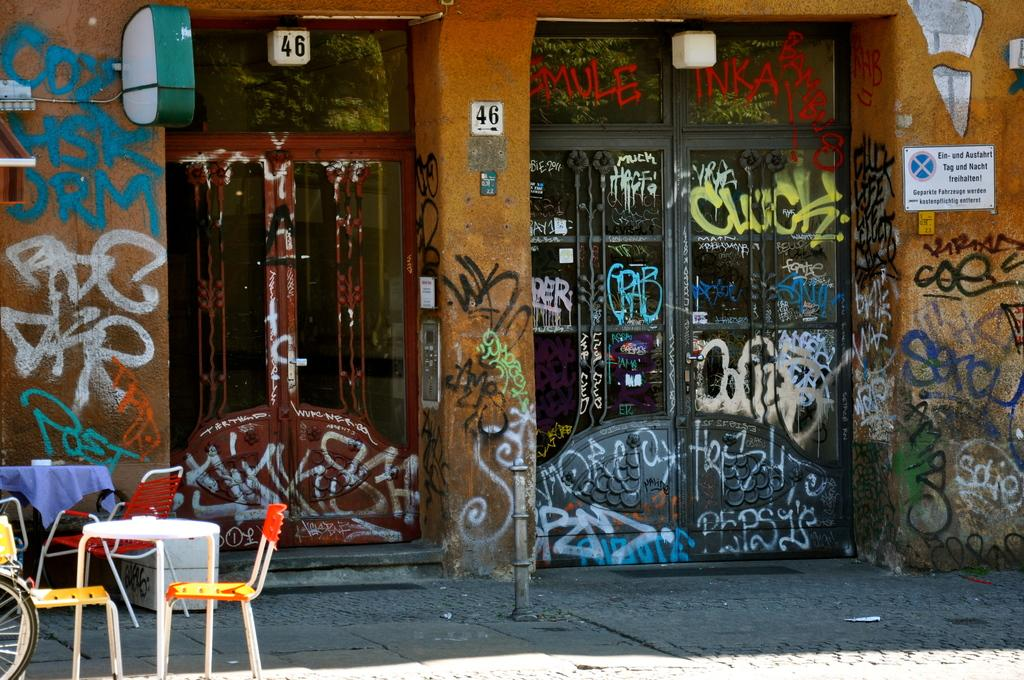What is one of the main architectural features in the image? There is a door in the image. What is the door attached to? The door is attached to a wall in the image. What decorative elements are present on the wall? There are paintings on the wall in the image. What piece of furniture can be seen in the image? There is a table in the image. What type of seating is visible on the floor? There are chairs on the floor in the image. What type of stamp can be seen on the door in the image? There is no stamp present on the door in the image. 